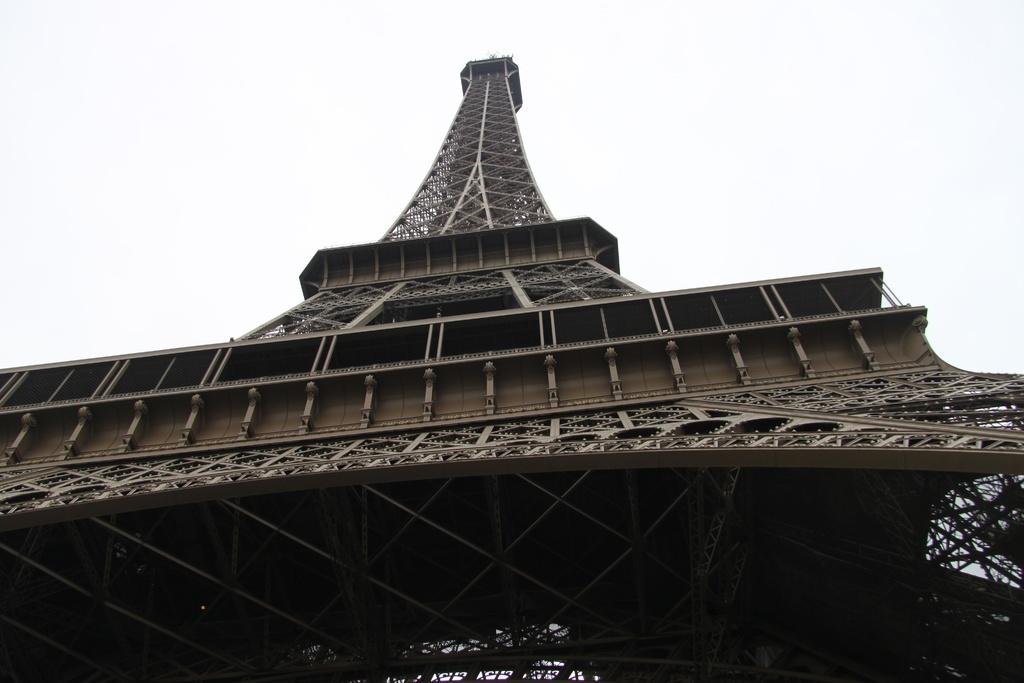What is the main subject in the center of the image? The Eiffel tower is in the center of the image. What can be seen in the background of the image? The sky is visible in the background of the image. Can you see any pollution in the image? There is no indication of pollution in the image; it only features the Eiffel tower and the sky. Is there a writer visible in the image? There is no writer present in the image. 